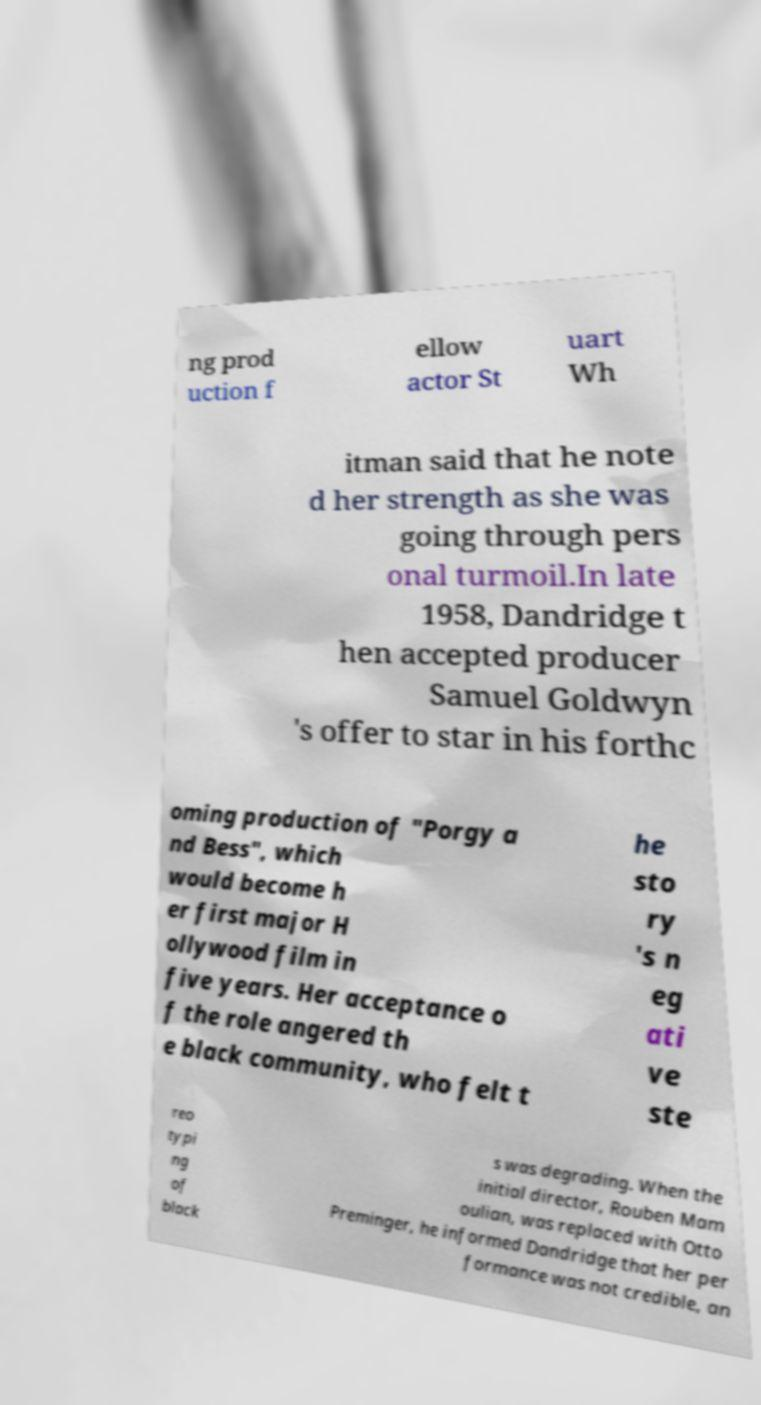Can you read and provide the text displayed in the image?This photo seems to have some interesting text. Can you extract and type it out for me? ng prod uction f ellow actor St uart Wh itman said that he note d her strength as she was going through pers onal turmoil.In late 1958, Dandridge t hen accepted producer Samuel Goldwyn 's offer to star in his forthc oming production of "Porgy a nd Bess", which would become h er first major H ollywood film in five years. Her acceptance o f the role angered th e black community, who felt t he sto ry 's n eg ati ve ste reo typi ng of black s was degrading. When the initial director, Rouben Mam oulian, was replaced with Otto Preminger, he informed Dandridge that her per formance was not credible, an 